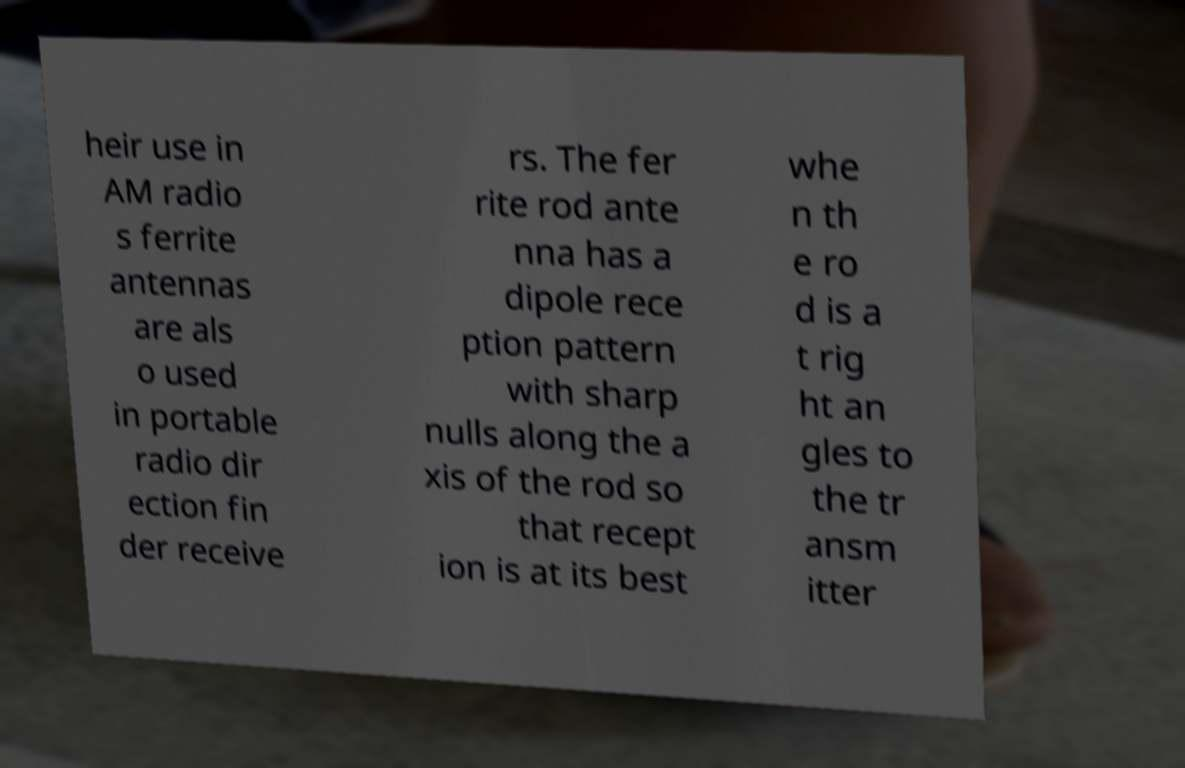I need the written content from this picture converted into text. Can you do that? heir use in AM radio s ferrite antennas are als o used in portable radio dir ection fin der receive rs. The fer rite rod ante nna has a dipole rece ption pattern with sharp nulls along the a xis of the rod so that recept ion is at its best whe n th e ro d is a t rig ht an gles to the tr ansm itter 